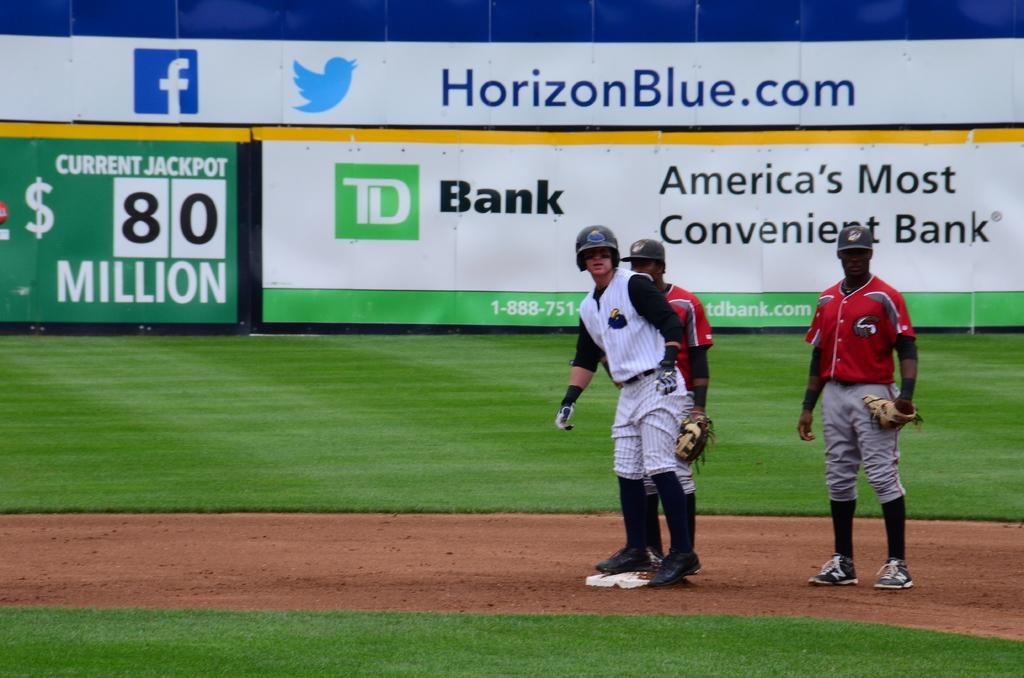<image>
Present a compact description of the photo's key features. Baseball stadium with a banner that has America's Most Convenient Bank in black letters. 